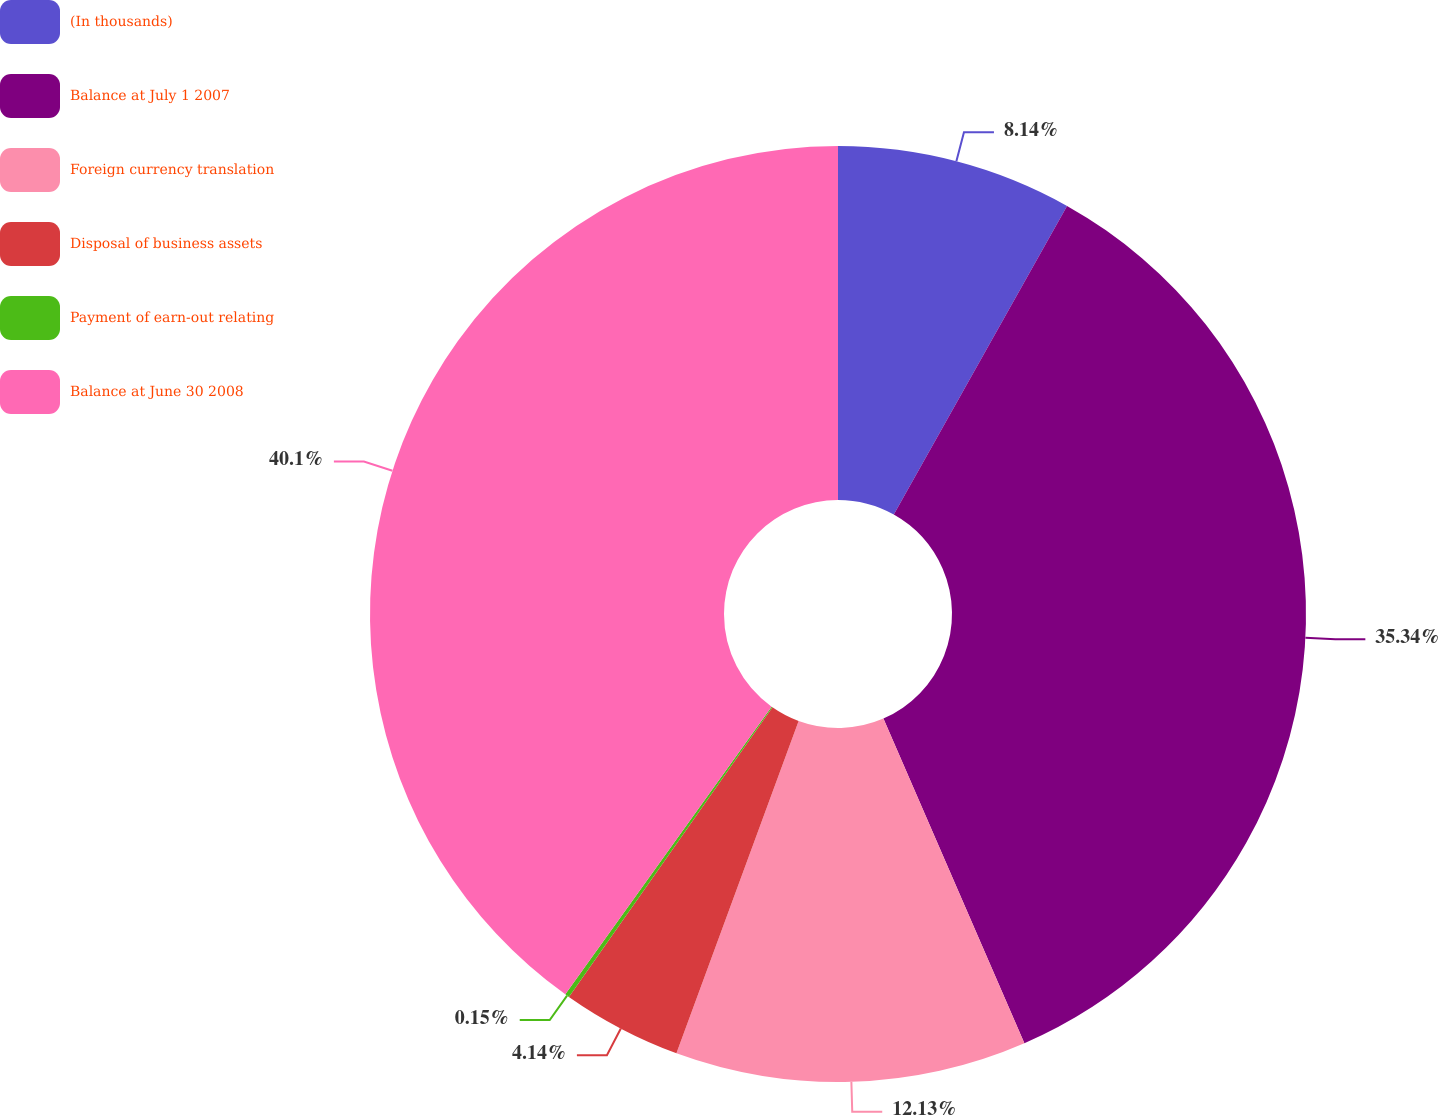Convert chart to OTSL. <chart><loc_0><loc_0><loc_500><loc_500><pie_chart><fcel>(In thousands)<fcel>Balance at July 1 2007<fcel>Foreign currency translation<fcel>Disposal of business assets<fcel>Payment of earn-out relating<fcel>Balance at June 30 2008<nl><fcel>8.14%<fcel>35.34%<fcel>12.13%<fcel>4.14%<fcel>0.15%<fcel>40.1%<nl></chart> 